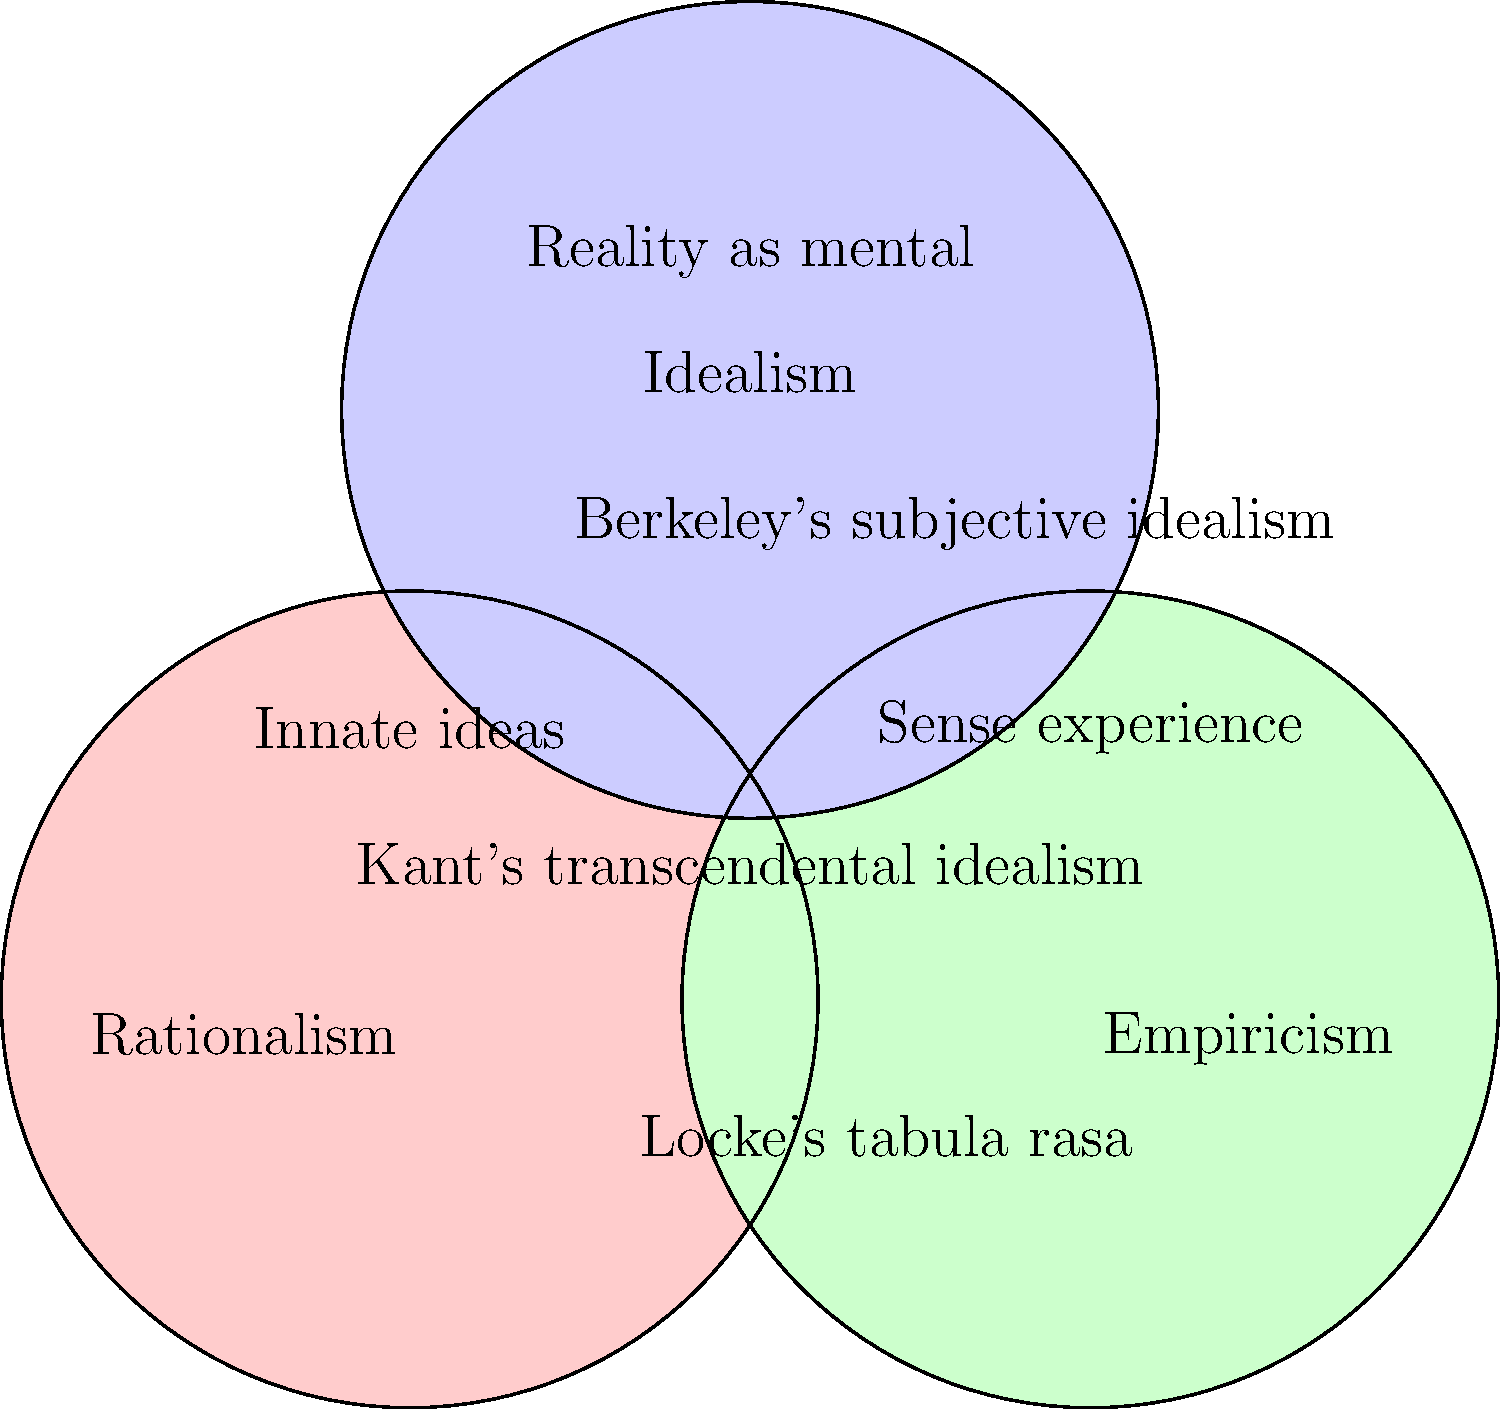Analyze the Venn diagram depicting the relationships between Rationalism, Empiricism, and Idealism. Which philosopher's ideas are represented by the central intersection of all three schools of thought, and why is this positioning significant in the history of philosophy? To answer this question, let's analyze the diagram step-by-step:

1. The diagram shows three overlapping circles representing Rationalism, Empiricism, and Idealism.

2. Rationalism (red circle) emphasizes innate ideas and reason as the primary source of knowledge.

3. Empiricism (green circle) focuses on sense experience as the main source of knowledge.

4. Idealism (blue circle) posits that reality is fundamentally mental or spiritual in nature.

5. The central intersection, where all three circles overlap, is labeled "Kant's transcendental idealism."

6. This positioning is significant because Immanuel Kant's philosophy attempted to synthesize elements from all three schools of thought:

   a) From Rationalism: Kant argued for the existence of a priori knowledge (knowledge independent of experience).
   
   b) From Empiricism: He acknowledged the importance of sensory experience in acquiring knowledge.
   
   c) From Idealism: Kant proposed that the mind actively structures our experience of reality.

7. Kant's "Copernican Revolution" in philosophy aimed to reconcile the apparent contradictions between these schools of thought by proposing that while we can know things as they appear to us (phenomena), we cannot know things as they are in themselves (noumena).

8. This synthesis was a pivotal moment in the history of philosophy, as it addressed longstanding debates and set the stage for subsequent philosophical developments.
Answer: Kant's transcendental idealism, synthesizing elements of Rationalism, Empiricism, and Idealism. 